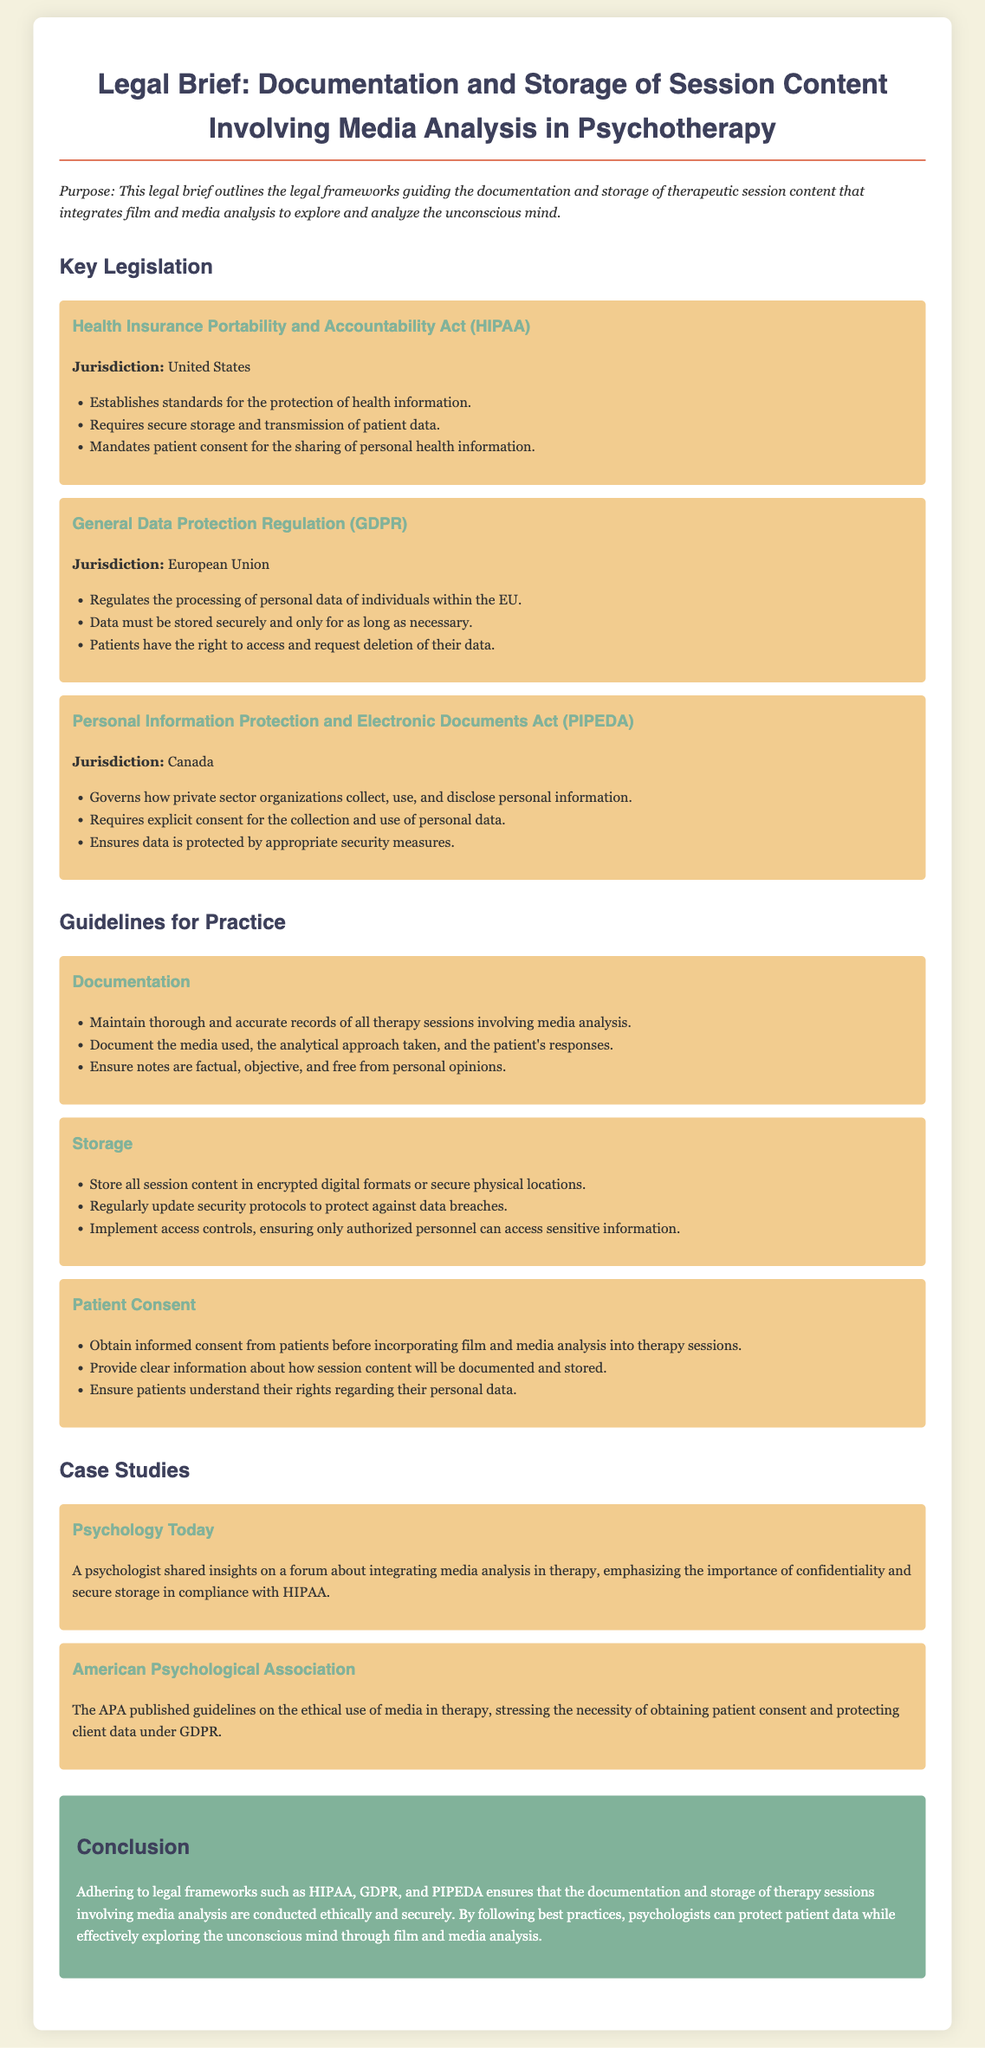What is the purpose of the legal brief? The purpose is outlined in the introduction, explaining the legal frameworks guiding the documentation and storage of therapy session content involving media analysis.
Answer: Legal frameworks guiding documentation and storage What legislation is mentioned regarding patient data protection in the United States? The document lists several key legislations, specifically highlighting those relevant to the U.S.
Answer: Health Insurance Portability and Accountability Act (HIPAA) Which regulation governs the processing of personal data in the European Union? The brief provides information on legislation pertinent to the EU, notably regarding data processing.
Answer: General Data Protection Regulation (GDPR) What is required by HIPAA before sharing personal health information? The legislation mentions a specific obligation that must be met before personal health information can be shared.
Answer: Patient consent What should psychologists obtain before incorporating media analysis into therapy sessions? This guideline emphasizes an essential requirement before using media analysis, reflecting the ethical considerations in practice.
Answer: Informed consent What does GDPR allow patients to do regarding their data? The document highlights specific rights granted to patients under this regulation, informing them about their data.
Answer: Access and request deletion What type of records should psychologists maintain according to the guidelines? The brief specifies what kind of records are necessary for documentation, emphasizing accuracy and thoroughness.
Answer: Thorough and accurate records What is emphasized in the case study from Psychology Today? This case study showcases insights concerning ethical practices in therapy, focused on a particular legal framework.
Answer: Importance of confidentiality and secure storage Which act governs personal information in Canada? The document lists a specific act that regulates how personal information is handled within Canada.
Answer: Personal Information Protection and Electronic Documents Act (PIPEDA) 